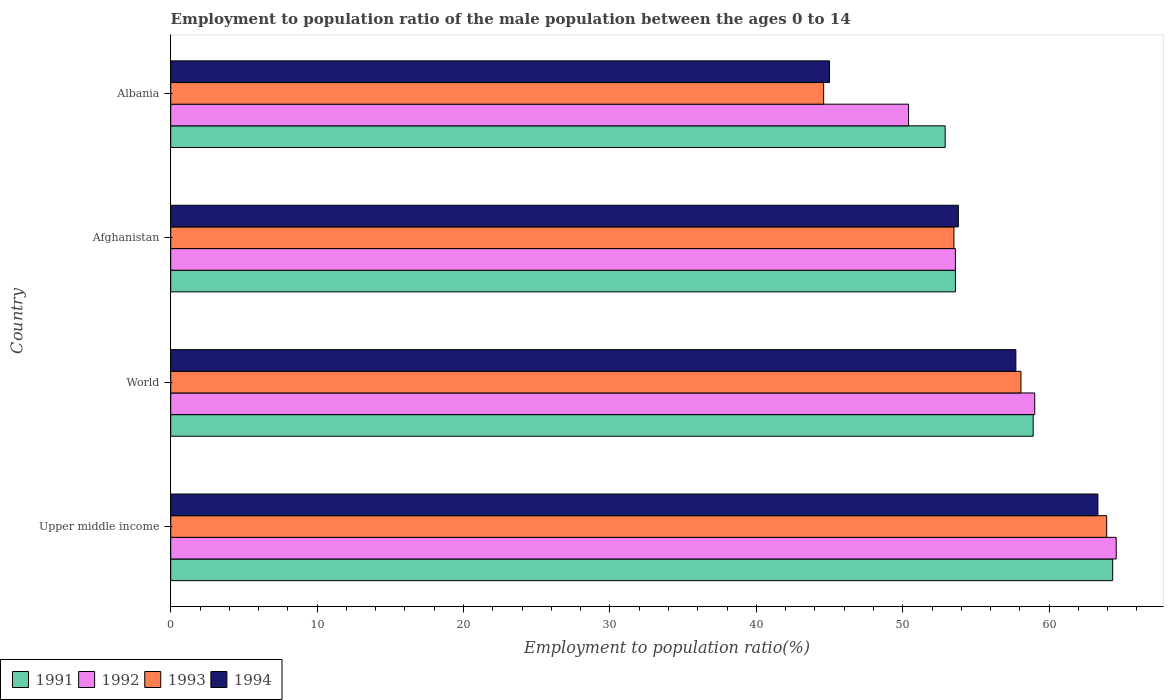How many different coloured bars are there?
Offer a very short reply. 4. How many groups of bars are there?
Offer a terse response. 4. Are the number of bars on each tick of the Y-axis equal?
Ensure brevity in your answer.  Yes. How many bars are there on the 1st tick from the bottom?
Provide a succinct answer. 4. What is the label of the 4th group of bars from the top?
Ensure brevity in your answer.  Upper middle income. What is the employment to population ratio in 1993 in Albania?
Provide a succinct answer. 44.6. Across all countries, what is the maximum employment to population ratio in 1992?
Your answer should be compact. 64.58. Across all countries, what is the minimum employment to population ratio in 1992?
Your response must be concise. 50.4. In which country was the employment to population ratio in 1994 maximum?
Offer a terse response. Upper middle income. In which country was the employment to population ratio in 1994 minimum?
Your answer should be very brief. Albania. What is the total employment to population ratio in 1993 in the graph?
Your answer should be compact. 220.11. What is the difference between the employment to population ratio in 1993 in Upper middle income and that in World?
Ensure brevity in your answer.  5.86. What is the difference between the employment to population ratio in 1991 in Albania and the employment to population ratio in 1993 in World?
Provide a short and direct response. -5.18. What is the average employment to population ratio in 1992 per country?
Make the answer very short. 56.9. What is the difference between the employment to population ratio in 1992 and employment to population ratio in 1994 in Upper middle income?
Offer a very short reply. 1.25. What is the ratio of the employment to population ratio in 1994 in Afghanistan to that in World?
Offer a terse response. 0.93. What is the difference between the highest and the second highest employment to population ratio in 1994?
Your answer should be very brief. 5.6. What is the difference between the highest and the lowest employment to population ratio in 1991?
Provide a short and direct response. 11.44. What does the 1st bar from the top in Afghanistan represents?
Your answer should be very brief. 1994. Is it the case that in every country, the sum of the employment to population ratio in 1992 and employment to population ratio in 1991 is greater than the employment to population ratio in 1994?
Your answer should be compact. Yes. What is the difference between two consecutive major ticks on the X-axis?
Ensure brevity in your answer.  10. Are the values on the major ticks of X-axis written in scientific E-notation?
Your answer should be very brief. No. How many legend labels are there?
Give a very brief answer. 4. What is the title of the graph?
Ensure brevity in your answer.  Employment to population ratio of the male population between the ages 0 to 14. Does "1982" appear as one of the legend labels in the graph?
Keep it short and to the point. No. What is the label or title of the X-axis?
Offer a very short reply. Employment to population ratio(%). What is the Employment to population ratio(%) of 1991 in Upper middle income?
Offer a very short reply. 64.34. What is the Employment to population ratio(%) in 1992 in Upper middle income?
Your answer should be compact. 64.58. What is the Employment to population ratio(%) of 1993 in Upper middle income?
Keep it short and to the point. 63.93. What is the Employment to population ratio(%) in 1994 in Upper middle income?
Provide a short and direct response. 63.33. What is the Employment to population ratio(%) of 1991 in World?
Ensure brevity in your answer.  58.91. What is the Employment to population ratio(%) in 1992 in World?
Offer a very short reply. 59.02. What is the Employment to population ratio(%) of 1993 in World?
Ensure brevity in your answer.  58.08. What is the Employment to population ratio(%) of 1994 in World?
Offer a terse response. 57.73. What is the Employment to population ratio(%) of 1991 in Afghanistan?
Keep it short and to the point. 53.6. What is the Employment to population ratio(%) of 1992 in Afghanistan?
Keep it short and to the point. 53.6. What is the Employment to population ratio(%) of 1993 in Afghanistan?
Keep it short and to the point. 53.5. What is the Employment to population ratio(%) in 1994 in Afghanistan?
Provide a short and direct response. 53.8. What is the Employment to population ratio(%) of 1991 in Albania?
Your response must be concise. 52.9. What is the Employment to population ratio(%) of 1992 in Albania?
Your answer should be very brief. 50.4. What is the Employment to population ratio(%) of 1993 in Albania?
Your answer should be compact. 44.6. What is the Employment to population ratio(%) of 1994 in Albania?
Your response must be concise. 45. Across all countries, what is the maximum Employment to population ratio(%) of 1991?
Offer a terse response. 64.34. Across all countries, what is the maximum Employment to population ratio(%) of 1992?
Offer a very short reply. 64.58. Across all countries, what is the maximum Employment to population ratio(%) of 1993?
Provide a short and direct response. 63.93. Across all countries, what is the maximum Employment to population ratio(%) in 1994?
Your response must be concise. 63.33. Across all countries, what is the minimum Employment to population ratio(%) of 1991?
Your answer should be compact. 52.9. Across all countries, what is the minimum Employment to population ratio(%) of 1992?
Provide a short and direct response. 50.4. Across all countries, what is the minimum Employment to population ratio(%) of 1993?
Provide a short and direct response. 44.6. Across all countries, what is the minimum Employment to population ratio(%) in 1994?
Provide a short and direct response. 45. What is the total Employment to population ratio(%) in 1991 in the graph?
Ensure brevity in your answer.  229.76. What is the total Employment to population ratio(%) in 1992 in the graph?
Provide a short and direct response. 227.6. What is the total Employment to population ratio(%) in 1993 in the graph?
Provide a short and direct response. 220.11. What is the total Employment to population ratio(%) of 1994 in the graph?
Your answer should be compact. 219.86. What is the difference between the Employment to population ratio(%) of 1991 in Upper middle income and that in World?
Your answer should be very brief. 5.43. What is the difference between the Employment to population ratio(%) of 1992 in Upper middle income and that in World?
Offer a very short reply. 5.57. What is the difference between the Employment to population ratio(%) of 1993 in Upper middle income and that in World?
Provide a succinct answer. 5.86. What is the difference between the Employment to population ratio(%) in 1994 in Upper middle income and that in World?
Provide a short and direct response. 5.6. What is the difference between the Employment to population ratio(%) in 1991 in Upper middle income and that in Afghanistan?
Provide a short and direct response. 10.74. What is the difference between the Employment to population ratio(%) of 1992 in Upper middle income and that in Afghanistan?
Ensure brevity in your answer.  10.98. What is the difference between the Employment to population ratio(%) in 1993 in Upper middle income and that in Afghanistan?
Offer a terse response. 10.43. What is the difference between the Employment to population ratio(%) in 1994 in Upper middle income and that in Afghanistan?
Your answer should be very brief. 9.53. What is the difference between the Employment to population ratio(%) in 1991 in Upper middle income and that in Albania?
Provide a short and direct response. 11.44. What is the difference between the Employment to population ratio(%) in 1992 in Upper middle income and that in Albania?
Provide a succinct answer. 14.18. What is the difference between the Employment to population ratio(%) in 1993 in Upper middle income and that in Albania?
Make the answer very short. 19.33. What is the difference between the Employment to population ratio(%) of 1994 in Upper middle income and that in Albania?
Make the answer very short. 18.33. What is the difference between the Employment to population ratio(%) of 1991 in World and that in Afghanistan?
Provide a succinct answer. 5.31. What is the difference between the Employment to population ratio(%) in 1992 in World and that in Afghanistan?
Keep it short and to the point. 5.42. What is the difference between the Employment to population ratio(%) in 1993 in World and that in Afghanistan?
Make the answer very short. 4.58. What is the difference between the Employment to population ratio(%) in 1994 in World and that in Afghanistan?
Offer a very short reply. 3.93. What is the difference between the Employment to population ratio(%) in 1991 in World and that in Albania?
Give a very brief answer. 6.01. What is the difference between the Employment to population ratio(%) of 1992 in World and that in Albania?
Provide a succinct answer. 8.62. What is the difference between the Employment to population ratio(%) of 1993 in World and that in Albania?
Your answer should be compact. 13.48. What is the difference between the Employment to population ratio(%) of 1994 in World and that in Albania?
Offer a very short reply. 12.73. What is the difference between the Employment to population ratio(%) in 1991 in Afghanistan and that in Albania?
Offer a very short reply. 0.7. What is the difference between the Employment to population ratio(%) of 1991 in Upper middle income and the Employment to population ratio(%) of 1992 in World?
Make the answer very short. 5.33. What is the difference between the Employment to population ratio(%) of 1991 in Upper middle income and the Employment to population ratio(%) of 1993 in World?
Your response must be concise. 6.27. What is the difference between the Employment to population ratio(%) in 1991 in Upper middle income and the Employment to population ratio(%) in 1994 in World?
Your answer should be compact. 6.61. What is the difference between the Employment to population ratio(%) of 1992 in Upper middle income and the Employment to population ratio(%) of 1993 in World?
Provide a succinct answer. 6.51. What is the difference between the Employment to population ratio(%) in 1992 in Upper middle income and the Employment to population ratio(%) in 1994 in World?
Ensure brevity in your answer.  6.85. What is the difference between the Employment to population ratio(%) of 1993 in Upper middle income and the Employment to population ratio(%) of 1994 in World?
Make the answer very short. 6.2. What is the difference between the Employment to population ratio(%) of 1991 in Upper middle income and the Employment to population ratio(%) of 1992 in Afghanistan?
Keep it short and to the point. 10.74. What is the difference between the Employment to population ratio(%) in 1991 in Upper middle income and the Employment to population ratio(%) in 1993 in Afghanistan?
Give a very brief answer. 10.84. What is the difference between the Employment to population ratio(%) of 1991 in Upper middle income and the Employment to population ratio(%) of 1994 in Afghanistan?
Ensure brevity in your answer.  10.54. What is the difference between the Employment to population ratio(%) of 1992 in Upper middle income and the Employment to population ratio(%) of 1993 in Afghanistan?
Give a very brief answer. 11.08. What is the difference between the Employment to population ratio(%) in 1992 in Upper middle income and the Employment to population ratio(%) in 1994 in Afghanistan?
Your response must be concise. 10.78. What is the difference between the Employment to population ratio(%) of 1993 in Upper middle income and the Employment to population ratio(%) of 1994 in Afghanistan?
Provide a short and direct response. 10.13. What is the difference between the Employment to population ratio(%) of 1991 in Upper middle income and the Employment to population ratio(%) of 1992 in Albania?
Ensure brevity in your answer.  13.94. What is the difference between the Employment to population ratio(%) in 1991 in Upper middle income and the Employment to population ratio(%) in 1993 in Albania?
Ensure brevity in your answer.  19.74. What is the difference between the Employment to population ratio(%) of 1991 in Upper middle income and the Employment to population ratio(%) of 1994 in Albania?
Make the answer very short. 19.34. What is the difference between the Employment to population ratio(%) in 1992 in Upper middle income and the Employment to population ratio(%) in 1993 in Albania?
Offer a very short reply. 19.98. What is the difference between the Employment to population ratio(%) of 1992 in Upper middle income and the Employment to population ratio(%) of 1994 in Albania?
Offer a terse response. 19.58. What is the difference between the Employment to population ratio(%) in 1993 in Upper middle income and the Employment to population ratio(%) in 1994 in Albania?
Your answer should be compact. 18.93. What is the difference between the Employment to population ratio(%) in 1991 in World and the Employment to population ratio(%) in 1992 in Afghanistan?
Provide a succinct answer. 5.31. What is the difference between the Employment to population ratio(%) of 1991 in World and the Employment to population ratio(%) of 1993 in Afghanistan?
Your response must be concise. 5.41. What is the difference between the Employment to population ratio(%) of 1991 in World and the Employment to population ratio(%) of 1994 in Afghanistan?
Provide a succinct answer. 5.11. What is the difference between the Employment to population ratio(%) in 1992 in World and the Employment to population ratio(%) in 1993 in Afghanistan?
Ensure brevity in your answer.  5.52. What is the difference between the Employment to population ratio(%) of 1992 in World and the Employment to population ratio(%) of 1994 in Afghanistan?
Ensure brevity in your answer.  5.22. What is the difference between the Employment to population ratio(%) of 1993 in World and the Employment to population ratio(%) of 1994 in Afghanistan?
Make the answer very short. 4.28. What is the difference between the Employment to population ratio(%) of 1991 in World and the Employment to population ratio(%) of 1992 in Albania?
Your answer should be very brief. 8.51. What is the difference between the Employment to population ratio(%) of 1991 in World and the Employment to population ratio(%) of 1993 in Albania?
Your response must be concise. 14.31. What is the difference between the Employment to population ratio(%) of 1991 in World and the Employment to population ratio(%) of 1994 in Albania?
Your response must be concise. 13.91. What is the difference between the Employment to population ratio(%) of 1992 in World and the Employment to population ratio(%) of 1993 in Albania?
Keep it short and to the point. 14.42. What is the difference between the Employment to population ratio(%) of 1992 in World and the Employment to population ratio(%) of 1994 in Albania?
Your answer should be very brief. 14.02. What is the difference between the Employment to population ratio(%) in 1993 in World and the Employment to population ratio(%) in 1994 in Albania?
Provide a succinct answer. 13.08. What is the difference between the Employment to population ratio(%) of 1991 in Afghanistan and the Employment to population ratio(%) of 1992 in Albania?
Offer a terse response. 3.2. What is the difference between the Employment to population ratio(%) in 1991 in Afghanistan and the Employment to population ratio(%) in 1993 in Albania?
Offer a very short reply. 9. What is the difference between the Employment to population ratio(%) in 1991 in Afghanistan and the Employment to population ratio(%) in 1994 in Albania?
Your response must be concise. 8.6. What is the difference between the Employment to population ratio(%) of 1992 in Afghanistan and the Employment to population ratio(%) of 1993 in Albania?
Keep it short and to the point. 9. What is the difference between the Employment to population ratio(%) of 1993 in Afghanistan and the Employment to population ratio(%) of 1994 in Albania?
Ensure brevity in your answer.  8.5. What is the average Employment to population ratio(%) in 1991 per country?
Keep it short and to the point. 57.44. What is the average Employment to population ratio(%) in 1992 per country?
Offer a terse response. 56.9. What is the average Employment to population ratio(%) in 1993 per country?
Give a very brief answer. 55.03. What is the average Employment to population ratio(%) of 1994 per country?
Give a very brief answer. 54.97. What is the difference between the Employment to population ratio(%) of 1991 and Employment to population ratio(%) of 1992 in Upper middle income?
Ensure brevity in your answer.  -0.24. What is the difference between the Employment to population ratio(%) in 1991 and Employment to population ratio(%) in 1993 in Upper middle income?
Offer a terse response. 0.41. What is the difference between the Employment to population ratio(%) in 1991 and Employment to population ratio(%) in 1994 in Upper middle income?
Offer a very short reply. 1.01. What is the difference between the Employment to population ratio(%) of 1992 and Employment to population ratio(%) of 1993 in Upper middle income?
Make the answer very short. 0.65. What is the difference between the Employment to population ratio(%) in 1992 and Employment to population ratio(%) in 1994 in Upper middle income?
Offer a terse response. 1.25. What is the difference between the Employment to population ratio(%) of 1993 and Employment to population ratio(%) of 1994 in Upper middle income?
Make the answer very short. 0.6. What is the difference between the Employment to population ratio(%) in 1991 and Employment to population ratio(%) in 1992 in World?
Your response must be concise. -0.11. What is the difference between the Employment to population ratio(%) of 1991 and Employment to population ratio(%) of 1993 in World?
Your answer should be very brief. 0.83. What is the difference between the Employment to population ratio(%) in 1991 and Employment to population ratio(%) in 1994 in World?
Your response must be concise. 1.18. What is the difference between the Employment to population ratio(%) in 1992 and Employment to population ratio(%) in 1993 in World?
Give a very brief answer. 0.94. What is the difference between the Employment to population ratio(%) in 1992 and Employment to population ratio(%) in 1994 in World?
Offer a very short reply. 1.29. What is the difference between the Employment to population ratio(%) of 1993 and Employment to population ratio(%) of 1994 in World?
Ensure brevity in your answer.  0.35. What is the difference between the Employment to population ratio(%) in 1991 and Employment to population ratio(%) in 1992 in Afghanistan?
Keep it short and to the point. 0. What is the difference between the Employment to population ratio(%) of 1992 and Employment to population ratio(%) of 1994 in Afghanistan?
Offer a terse response. -0.2. What is the difference between the Employment to population ratio(%) in 1991 and Employment to population ratio(%) in 1992 in Albania?
Provide a short and direct response. 2.5. What is the difference between the Employment to population ratio(%) in 1991 and Employment to population ratio(%) in 1993 in Albania?
Keep it short and to the point. 8.3. What is the difference between the Employment to population ratio(%) in 1991 and Employment to population ratio(%) in 1994 in Albania?
Keep it short and to the point. 7.9. What is the difference between the Employment to population ratio(%) of 1992 and Employment to population ratio(%) of 1994 in Albania?
Your answer should be compact. 5.4. What is the ratio of the Employment to population ratio(%) of 1991 in Upper middle income to that in World?
Provide a short and direct response. 1.09. What is the ratio of the Employment to population ratio(%) in 1992 in Upper middle income to that in World?
Provide a short and direct response. 1.09. What is the ratio of the Employment to population ratio(%) in 1993 in Upper middle income to that in World?
Ensure brevity in your answer.  1.1. What is the ratio of the Employment to population ratio(%) of 1994 in Upper middle income to that in World?
Your answer should be very brief. 1.1. What is the ratio of the Employment to population ratio(%) in 1991 in Upper middle income to that in Afghanistan?
Your response must be concise. 1.2. What is the ratio of the Employment to population ratio(%) of 1992 in Upper middle income to that in Afghanistan?
Give a very brief answer. 1.2. What is the ratio of the Employment to population ratio(%) of 1993 in Upper middle income to that in Afghanistan?
Your response must be concise. 1.2. What is the ratio of the Employment to population ratio(%) of 1994 in Upper middle income to that in Afghanistan?
Provide a succinct answer. 1.18. What is the ratio of the Employment to population ratio(%) in 1991 in Upper middle income to that in Albania?
Give a very brief answer. 1.22. What is the ratio of the Employment to population ratio(%) in 1992 in Upper middle income to that in Albania?
Offer a terse response. 1.28. What is the ratio of the Employment to population ratio(%) in 1993 in Upper middle income to that in Albania?
Offer a terse response. 1.43. What is the ratio of the Employment to population ratio(%) of 1994 in Upper middle income to that in Albania?
Make the answer very short. 1.41. What is the ratio of the Employment to population ratio(%) in 1991 in World to that in Afghanistan?
Your answer should be very brief. 1.1. What is the ratio of the Employment to population ratio(%) of 1992 in World to that in Afghanistan?
Offer a terse response. 1.1. What is the ratio of the Employment to population ratio(%) in 1993 in World to that in Afghanistan?
Give a very brief answer. 1.09. What is the ratio of the Employment to population ratio(%) of 1994 in World to that in Afghanistan?
Provide a succinct answer. 1.07. What is the ratio of the Employment to population ratio(%) in 1991 in World to that in Albania?
Your response must be concise. 1.11. What is the ratio of the Employment to population ratio(%) of 1992 in World to that in Albania?
Your response must be concise. 1.17. What is the ratio of the Employment to population ratio(%) of 1993 in World to that in Albania?
Keep it short and to the point. 1.3. What is the ratio of the Employment to population ratio(%) of 1994 in World to that in Albania?
Offer a terse response. 1.28. What is the ratio of the Employment to population ratio(%) in 1991 in Afghanistan to that in Albania?
Your answer should be compact. 1.01. What is the ratio of the Employment to population ratio(%) in 1992 in Afghanistan to that in Albania?
Make the answer very short. 1.06. What is the ratio of the Employment to population ratio(%) in 1993 in Afghanistan to that in Albania?
Your response must be concise. 1.2. What is the ratio of the Employment to population ratio(%) of 1994 in Afghanistan to that in Albania?
Give a very brief answer. 1.2. What is the difference between the highest and the second highest Employment to population ratio(%) of 1991?
Provide a short and direct response. 5.43. What is the difference between the highest and the second highest Employment to population ratio(%) in 1992?
Provide a succinct answer. 5.57. What is the difference between the highest and the second highest Employment to population ratio(%) in 1993?
Provide a short and direct response. 5.86. What is the difference between the highest and the second highest Employment to population ratio(%) of 1994?
Your response must be concise. 5.6. What is the difference between the highest and the lowest Employment to population ratio(%) of 1991?
Keep it short and to the point. 11.44. What is the difference between the highest and the lowest Employment to population ratio(%) of 1992?
Offer a terse response. 14.18. What is the difference between the highest and the lowest Employment to population ratio(%) in 1993?
Your answer should be compact. 19.33. What is the difference between the highest and the lowest Employment to population ratio(%) in 1994?
Your response must be concise. 18.33. 